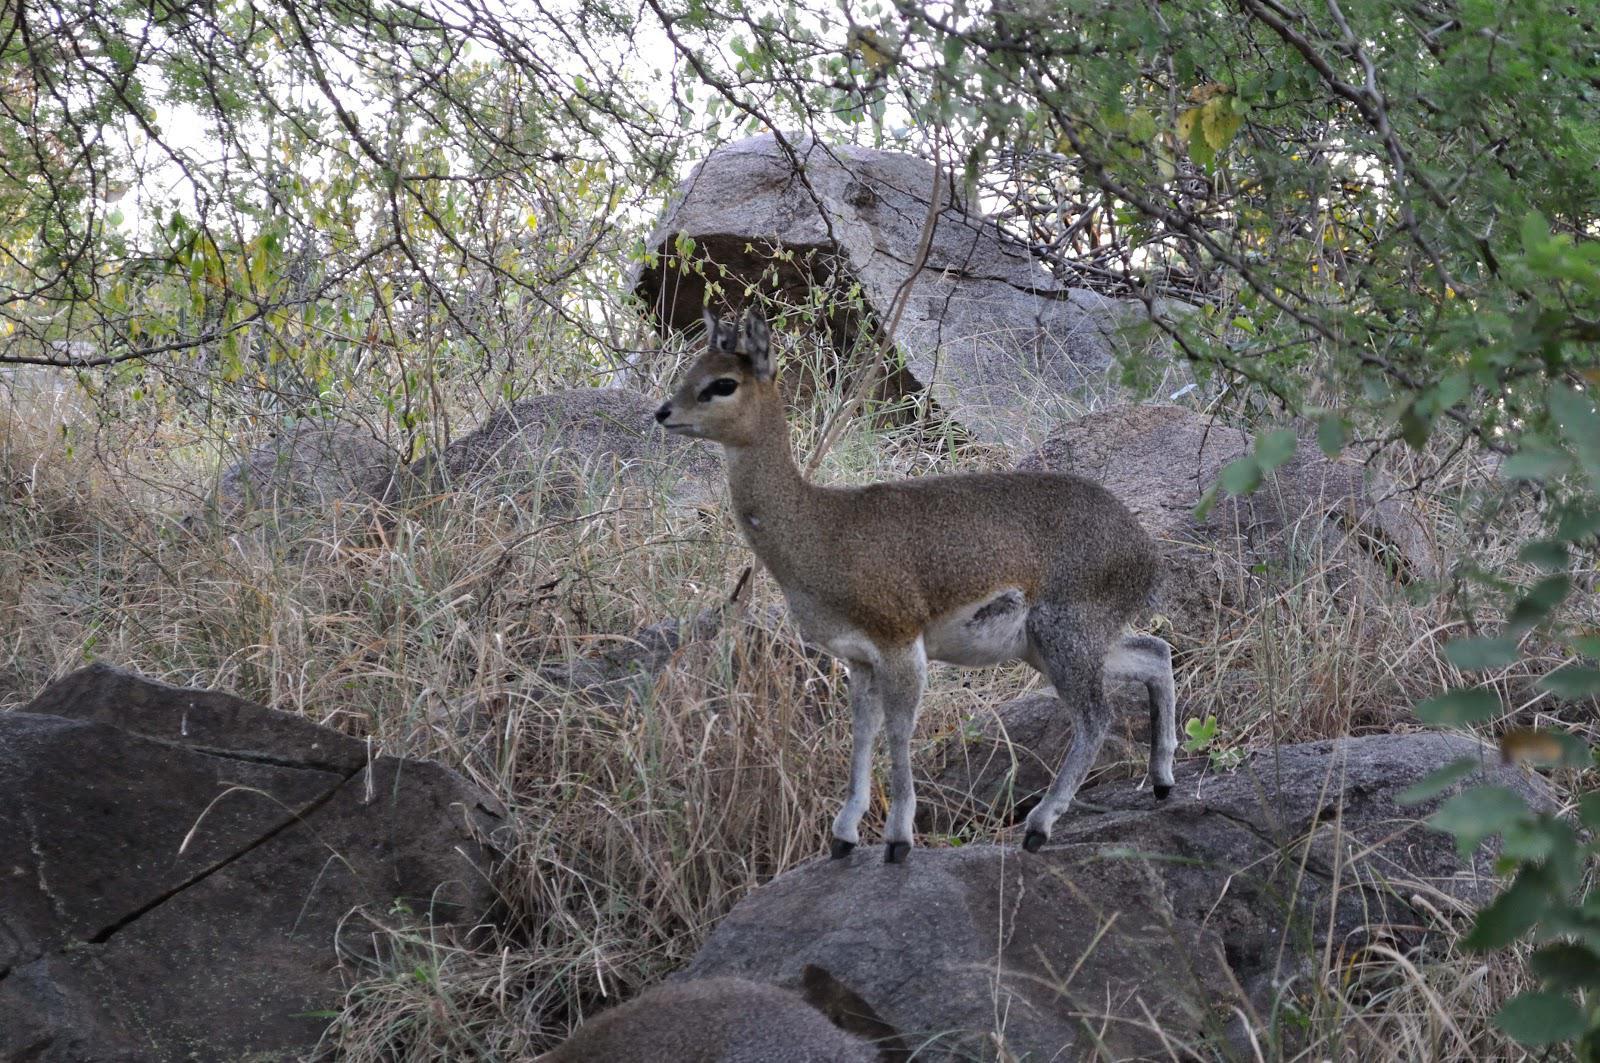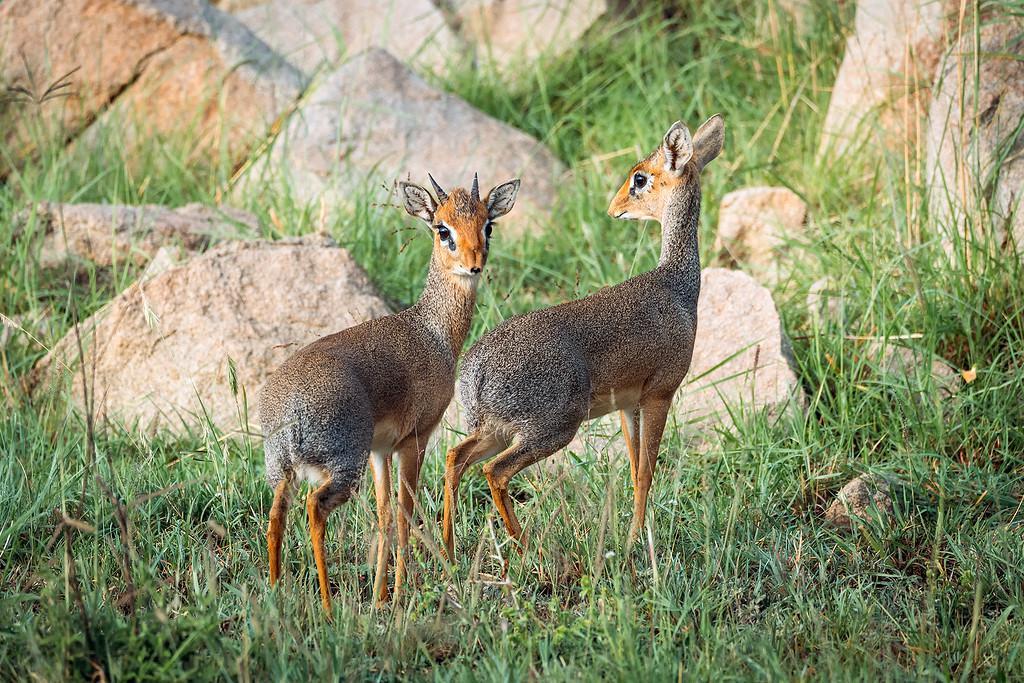The first image is the image on the left, the second image is the image on the right. Given the left and right images, does the statement "One image contains exactly twice as many hooved animals in the foreground as the other image." hold true? Answer yes or no. Yes. The first image is the image on the left, the second image is the image on the right. Given the left and right images, does the statement "The left and right image contains a total of three elk." hold true? Answer yes or no. Yes. 